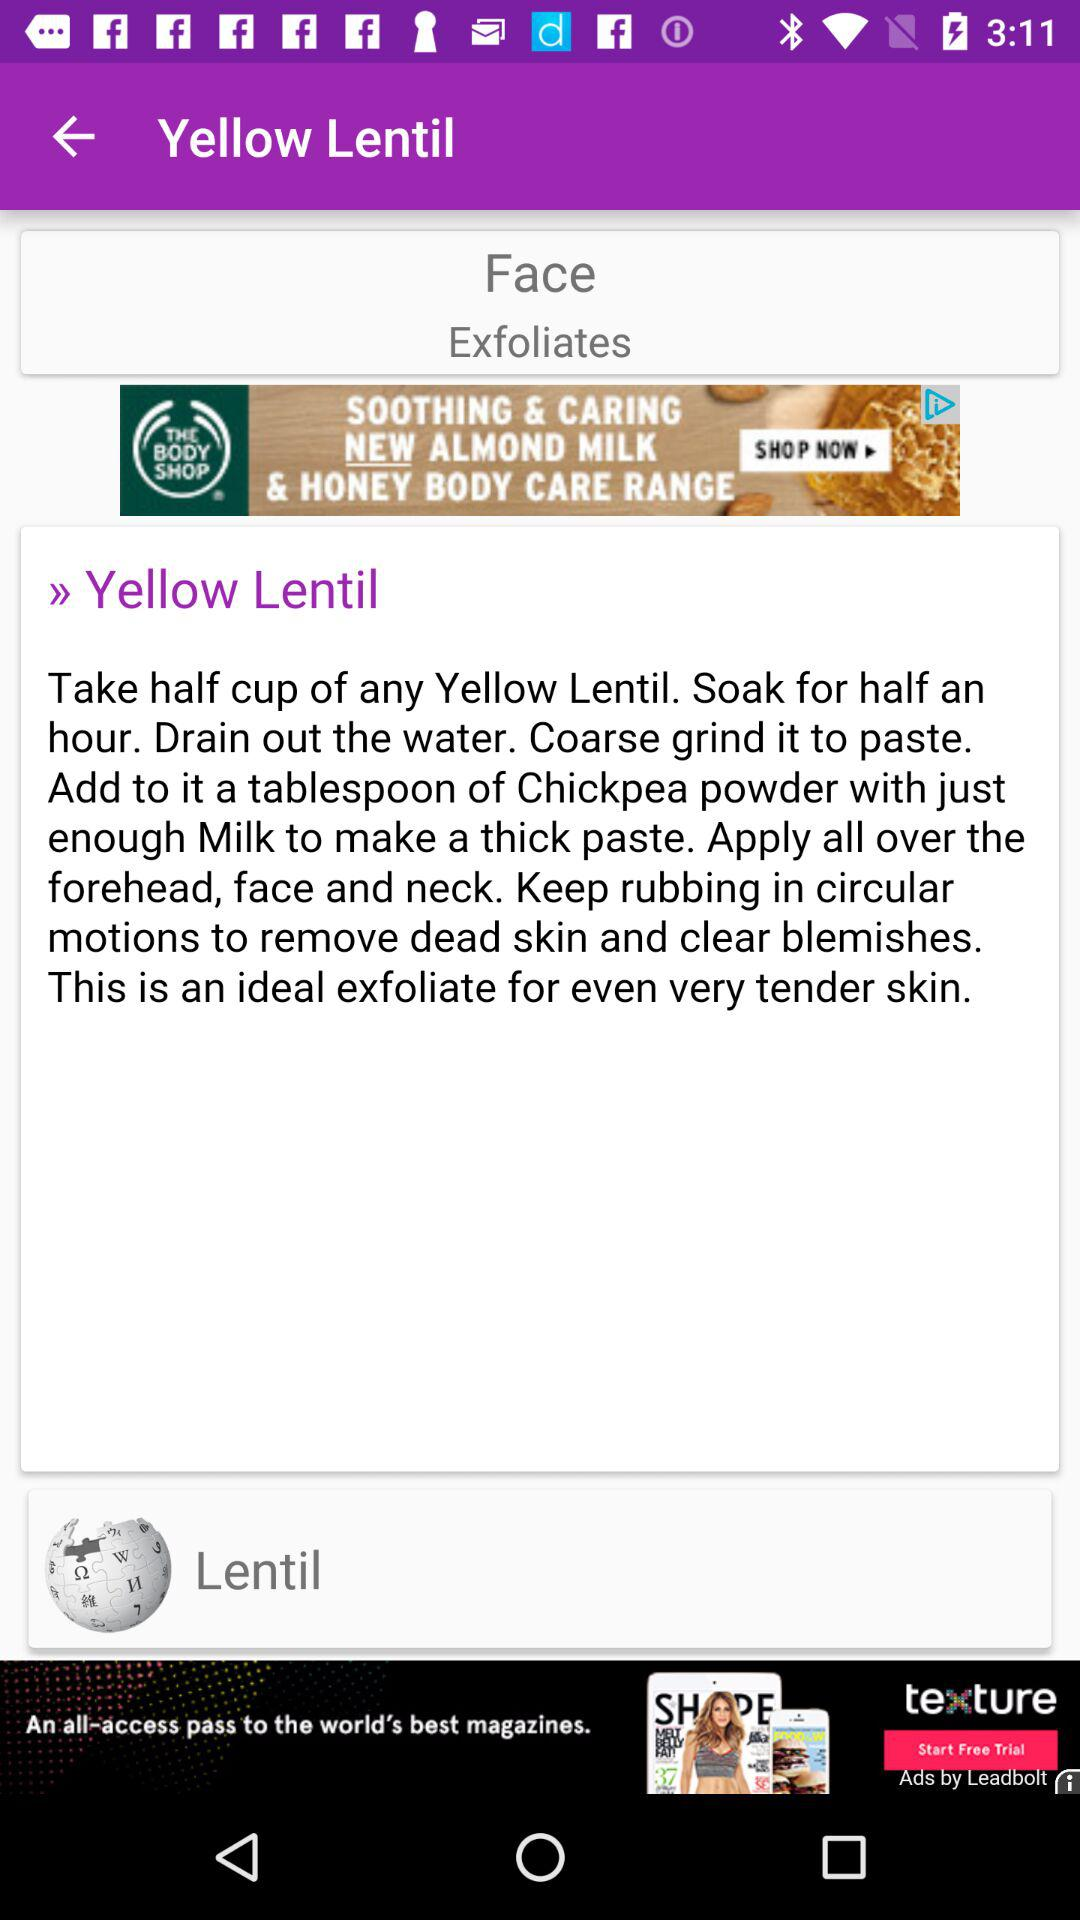What is the soaking time duration? The soaking time duration is half an hour. 